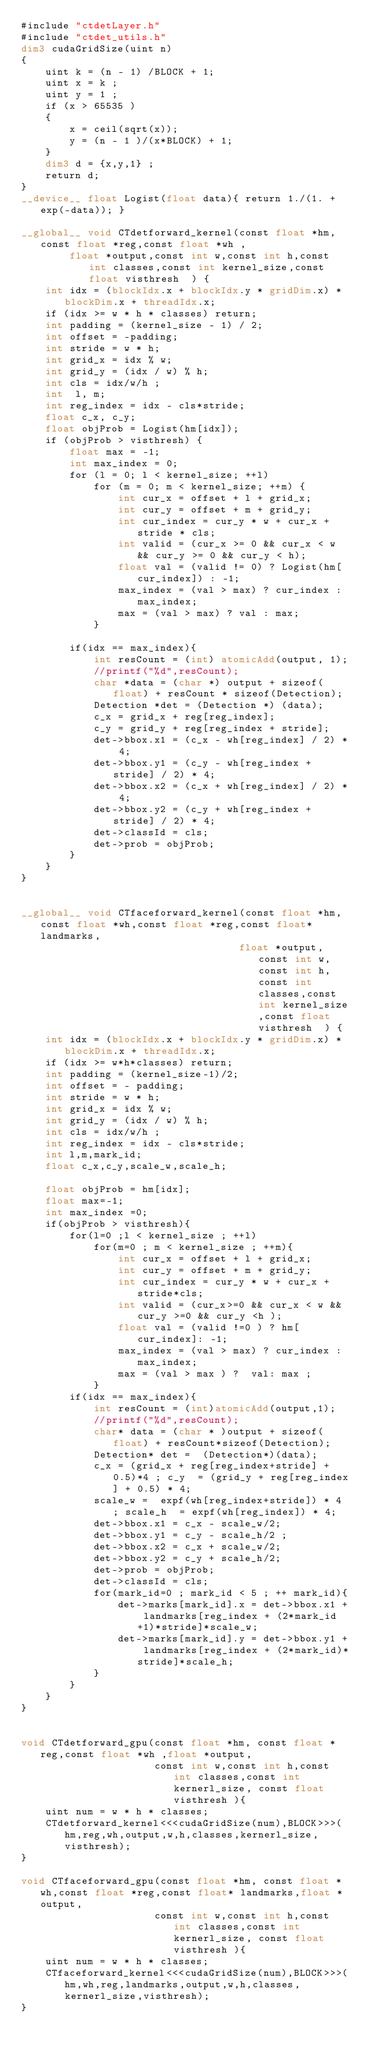Convert code to text. <code><loc_0><loc_0><loc_500><loc_500><_Cuda_>#include "ctdetLayer.h"
#include "ctdet_utils.h"
dim3 cudaGridSize(uint n)
{
    uint k = (n - 1) /BLOCK + 1;
    uint x = k ;
    uint y = 1 ;
    if (x > 65535 )
    {
        x = ceil(sqrt(x));
        y = (n - 1 )/(x*BLOCK) + 1;
    }
    dim3 d = {x,y,1} ;
    return d;
}
__device__ float Logist(float data){ return 1./(1. + exp(-data)); }

__global__ void CTdetforward_kernel(const float *hm, const float *reg,const float *wh ,
        float *output,const int w,const int h,const int classes,const int kernel_size,const float visthresh  ) {
    int idx = (blockIdx.x + blockIdx.y * gridDim.x) * blockDim.x + threadIdx.x;
    if (idx >= w * h * classes) return;
    int padding = (kernel_size - 1) / 2;
    int offset = -padding;
    int stride = w * h;
    int grid_x = idx % w;
    int grid_y = (idx / w) % h;
    int cls = idx/w/h ;
    int  l, m;
    int reg_index = idx - cls*stride;
    float c_x, c_y;
    float objProb = Logist(hm[idx]);
    if (objProb > visthresh) {
        float max = -1;
        int max_index = 0;
        for (l = 0; l < kernel_size; ++l)
            for (m = 0; m < kernel_size; ++m) {
                int cur_x = offset + l + grid_x;
                int cur_y = offset + m + grid_y;
                int cur_index = cur_y * w + cur_x + stride * cls;
                int valid = (cur_x >= 0 && cur_x < w && cur_y >= 0 && cur_y < h);
                float val = (valid != 0) ? Logist(hm[cur_index]) : -1;
                max_index = (val > max) ? cur_index : max_index;
                max = (val > max) ? val : max;
            }

        if(idx == max_index){
            int resCount = (int) atomicAdd(output, 1);
            //printf("%d",resCount);
            char *data = (char *) output + sizeof(float) + resCount * sizeof(Detection);
            Detection *det = (Detection *) (data);
            c_x = grid_x + reg[reg_index];
            c_y = grid_y + reg[reg_index + stride];
            det->bbox.x1 = (c_x - wh[reg_index] / 2) * 4;
            det->bbox.y1 = (c_y - wh[reg_index + stride] / 2) * 4;
            det->bbox.x2 = (c_x + wh[reg_index] / 2) * 4;
            det->bbox.y2 = (c_y + wh[reg_index + stride] / 2) * 4;
            det->classId = cls;
            det->prob = objProb;
        }
    }
}


__global__ void CTfaceforward_kernel(const float *hm, const float *wh,const float *reg,const float* landmarks,
                                    float *output,const int w,const int h,const int classes,const int kernel_size,const float visthresh  ) {
    int idx = (blockIdx.x + blockIdx.y * gridDim.x) * blockDim.x + threadIdx.x;
    if (idx >= w*h*classes) return;
    int padding = (kernel_size-1)/2;
    int offset = - padding;
    int stride = w * h;
    int grid_x = idx % w;
    int grid_y = (idx / w) % h;
    int cls = idx/w/h ;
    int reg_index = idx - cls*stride;
    int l,m,mark_id;
    float c_x,c_y,scale_w,scale_h;

    float objProb = hm[idx];
    float max=-1;
    int max_index =0;
    if(objProb > visthresh){
        for(l=0 ;l < kernel_size ; ++l)
            for(m=0 ; m < kernel_size ; ++m){
                int cur_x = offset + l + grid_x;
                int cur_y = offset + m + grid_y;
                int cur_index = cur_y * w + cur_x + stride*cls;
                int valid = (cur_x>=0 && cur_x < w && cur_y >=0 && cur_y <h );
                float val = (valid !=0 ) ? hm[cur_index]: -1;
                max_index = (val > max) ? cur_index : max_index;
                max = (val > max ) ?  val: max ;
            }
        if(idx == max_index){
            int resCount = (int)atomicAdd(output,1);
            //printf("%d",resCount);
            char* data = (char * )output + sizeof(float) + resCount*sizeof(Detection);
            Detection* det =  (Detection*)(data);
            c_x = (grid_x + reg[reg_index+stride] + 0.5)*4 ; c_y  = (grid_y + reg[reg_index] + 0.5) * 4;
            scale_w =  expf(wh[reg_index+stride]) * 4 ; scale_h  = expf(wh[reg_index]) * 4;
            det->bbox.x1 = c_x - scale_w/2;
            det->bbox.y1 = c_y - scale_h/2 ;
            det->bbox.x2 = c_x + scale_w/2;
            det->bbox.y2 = c_y + scale_h/2;
            det->prob = objProb;
            det->classId = cls;
            for(mark_id=0 ; mark_id < 5 ; ++ mark_id){
                det->marks[mark_id].x = det->bbox.x1 + landmarks[reg_index + (2*mark_id+1)*stride]*scale_w;
                det->marks[mark_id].y = det->bbox.y1 + landmarks[reg_index + (2*mark_id)*stride]*scale_h;
            }
        }
    }
}


void CTdetforward_gpu(const float *hm, const float *reg,const float *wh ,float *output,
                      const int w,const int h,const int classes,const int kernerl_size, const float visthresh ){
    uint num = w * h * classes;
    CTdetforward_kernel<<<cudaGridSize(num),BLOCK>>>(hm,reg,wh,output,w,h,classes,kernerl_size,visthresh);
}

void CTfaceforward_gpu(const float *hm, const float *wh,const float *reg,const float* landmarks,float *output,
                      const int w,const int h,const int classes,const int kernerl_size, const float visthresh ){
    uint num = w * h * classes;
    CTfaceforward_kernel<<<cudaGridSize(num),BLOCK>>>(hm,wh,reg,landmarks,output,w,h,classes,kernerl_size,visthresh);
}
</code> 